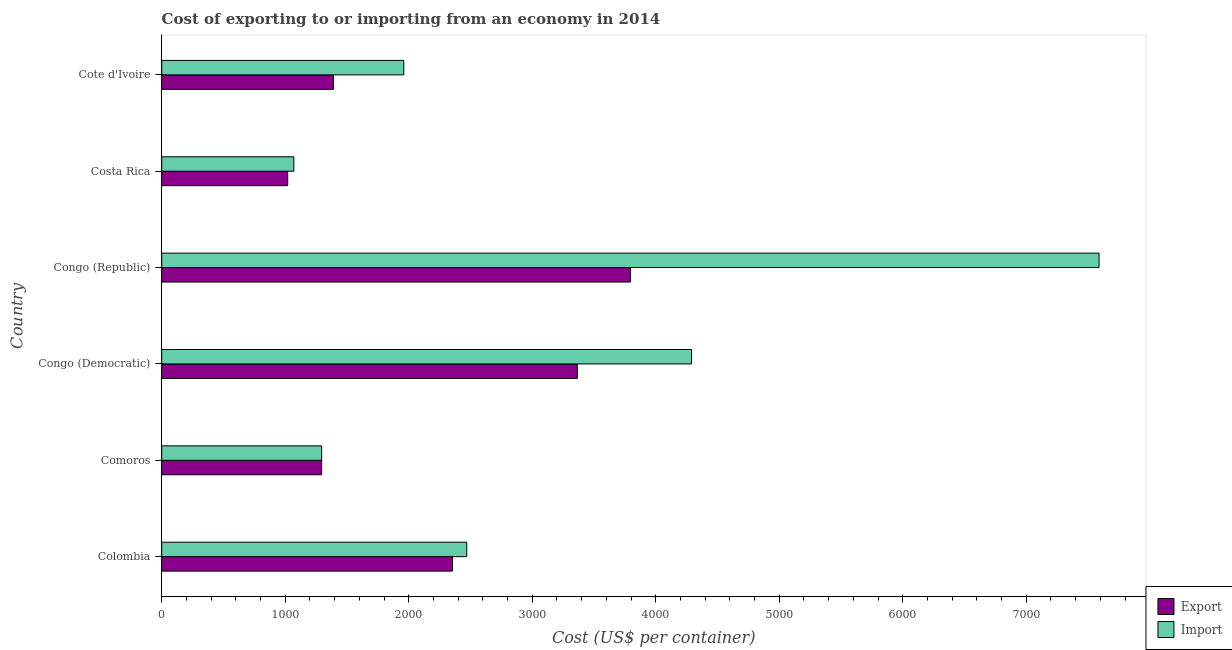Are the number of bars per tick equal to the number of legend labels?
Offer a very short reply. Yes. Are the number of bars on each tick of the Y-axis equal?
Provide a short and direct response. Yes. What is the label of the 5th group of bars from the top?
Give a very brief answer. Comoros. What is the import cost in Congo (Democratic)?
Your answer should be compact. 4290. Across all countries, what is the maximum export cost?
Keep it short and to the point. 3795. Across all countries, what is the minimum export cost?
Your answer should be very brief. 1020. In which country was the import cost maximum?
Make the answer very short. Congo (Republic). What is the total import cost in the graph?
Ensure brevity in your answer.  1.87e+04. What is the difference between the import cost in Colombia and that in Congo (Democratic)?
Keep it short and to the point. -1820. What is the difference between the export cost in Colombia and the import cost in Congo (Republic)?
Offer a terse response. -5235. What is the average export cost per country?
Make the answer very short. 2203.33. In how many countries, is the import cost greater than 7600 US$?
Make the answer very short. 0. What is the ratio of the export cost in Congo (Democratic) to that in Cote d'Ivoire?
Keep it short and to the point. 2.42. Is the export cost in Colombia less than that in Costa Rica?
Keep it short and to the point. No. Is the difference between the import cost in Comoros and Cote d'Ivoire greater than the difference between the export cost in Comoros and Cote d'Ivoire?
Your response must be concise. No. What is the difference between the highest and the second highest export cost?
Offer a very short reply. 430. What is the difference between the highest and the lowest export cost?
Ensure brevity in your answer.  2775. Is the sum of the export cost in Colombia and Cote d'Ivoire greater than the maximum import cost across all countries?
Offer a very short reply. No. What does the 2nd bar from the top in Cote d'Ivoire represents?
Keep it short and to the point. Export. What does the 2nd bar from the bottom in Costa Rica represents?
Your response must be concise. Import. How many countries are there in the graph?
Provide a short and direct response. 6. What is the difference between two consecutive major ticks on the X-axis?
Your answer should be very brief. 1000. Are the values on the major ticks of X-axis written in scientific E-notation?
Offer a terse response. No. Does the graph contain grids?
Keep it short and to the point. No. What is the title of the graph?
Make the answer very short. Cost of exporting to or importing from an economy in 2014. What is the label or title of the X-axis?
Provide a succinct answer. Cost (US$ per container). What is the Cost (US$ per container) of Export in Colombia?
Provide a short and direct response. 2355. What is the Cost (US$ per container) of Import in Colombia?
Make the answer very short. 2470. What is the Cost (US$ per container) of Export in Comoros?
Provide a short and direct response. 1295. What is the Cost (US$ per container) of Import in Comoros?
Your response must be concise. 1295. What is the Cost (US$ per container) of Export in Congo (Democratic)?
Provide a short and direct response. 3365. What is the Cost (US$ per container) of Import in Congo (Democratic)?
Provide a short and direct response. 4290. What is the Cost (US$ per container) in Export in Congo (Republic)?
Your answer should be very brief. 3795. What is the Cost (US$ per container) in Import in Congo (Republic)?
Provide a succinct answer. 7590. What is the Cost (US$ per container) in Export in Costa Rica?
Your answer should be very brief. 1020. What is the Cost (US$ per container) in Import in Costa Rica?
Offer a terse response. 1070. What is the Cost (US$ per container) in Export in Cote d'Ivoire?
Give a very brief answer. 1390. What is the Cost (US$ per container) of Import in Cote d'Ivoire?
Provide a short and direct response. 1960. Across all countries, what is the maximum Cost (US$ per container) in Export?
Provide a short and direct response. 3795. Across all countries, what is the maximum Cost (US$ per container) of Import?
Your answer should be very brief. 7590. Across all countries, what is the minimum Cost (US$ per container) in Export?
Offer a very short reply. 1020. Across all countries, what is the minimum Cost (US$ per container) of Import?
Your answer should be very brief. 1070. What is the total Cost (US$ per container) in Export in the graph?
Provide a succinct answer. 1.32e+04. What is the total Cost (US$ per container) in Import in the graph?
Make the answer very short. 1.87e+04. What is the difference between the Cost (US$ per container) of Export in Colombia and that in Comoros?
Provide a succinct answer. 1060. What is the difference between the Cost (US$ per container) in Import in Colombia and that in Comoros?
Your answer should be compact. 1175. What is the difference between the Cost (US$ per container) of Export in Colombia and that in Congo (Democratic)?
Provide a succinct answer. -1010. What is the difference between the Cost (US$ per container) of Import in Colombia and that in Congo (Democratic)?
Provide a short and direct response. -1820. What is the difference between the Cost (US$ per container) of Export in Colombia and that in Congo (Republic)?
Provide a short and direct response. -1440. What is the difference between the Cost (US$ per container) of Import in Colombia and that in Congo (Republic)?
Offer a very short reply. -5120. What is the difference between the Cost (US$ per container) in Export in Colombia and that in Costa Rica?
Make the answer very short. 1335. What is the difference between the Cost (US$ per container) in Import in Colombia and that in Costa Rica?
Make the answer very short. 1400. What is the difference between the Cost (US$ per container) of Export in Colombia and that in Cote d'Ivoire?
Your answer should be very brief. 965. What is the difference between the Cost (US$ per container) of Import in Colombia and that in Cote d'Ivoire?
Provide a succinct answer. 510. What is the difference between the Cost (US$ per container) of Export in Comoros and that in Congo (Democratic)?
Your answer should be very brief. -2070. What is the difference between the Cost (US$ per container) of Import in Comoros and that in Congo (Democratic)?
Your answer should be compact. -2995. What is the difference between the Cost (US$ per container) of Export in Comoros and that in Congo (Republic)?
Your response must be concise. -2500. What is the difference between the Cost (US$ per container) in Import in Comoros and that in Congo (Republic)?
Your answer should be very brief. -6295. What is the difference between the Cost (US$ per container) of Export in Comoros and that in Costa Rica?
Your answer should be compact. 275. What is the difference between the Cost (US$ per container) of Import in Comoros and that in Costa Rica?
Your answer should be very brief. 225. What is the difference between the Cost (US$ per container) in Export in Comoros and that in Cote d'Ivoire?
Your response must be concise. -95. What is the difference between the Cost (US$ per container) in Import in Comoros and that in Cote d'Ivoire?
Your response must be concise. -665. What is the difference between the Cost (US$ per container) in Export in Congo (Democratic) and that in Congo (Republic)?
Give a very brief answer. -430. What is the difference between the Cost (US$ per container) of Import in Congo (Democratic) and that in Congo (Republic)?
Your response must be concise. -3300. What is the difference between the Cost (US$ per container) of Export in Congo (Democratic) and that in Costa Rica?
Provide a short and direct response. 2345. What is the difference between the Cost (US$ per container) of Import in Congo (Democratic) and that in Costa Rica?
Ensure brevity in your answer.  3220. What is the difference between the Cost (US$ per container) in Export in Congo (Democratic) and that in Cote d'Ivoire?
Keep it short and to the point. 1975. What is the difference between the Cost (US$ per container) in Import in Congo (Democratic) and that in Cote d'Ivoire?
Provide a succinct answer. 2330. What is the difference between the Cost (US$ per container) in Export in Congo (Republic) and that in Costa Rica?
Your answer should be very brief. 2775. What is the difference between the Cost (US$ per container) of Import in Congo (Republic) and that in Costa Rica?
Keep it short and to the point. 6520. What is the difference between the Cost (US$ per container) of Export in Congo (Republic) and that in Cote d'Ivoire?
Your answer should be very brief. 2405. What is the difference between the Cost (US$ per container) in Import in Congo (Republic) and that in Cote d'Ivoire?
Make the answer very short. 5630. What is the difference between the Cost (US$ per container) in Export in Costa Rica and that in Cote d'Ivoire?
Your answer should be compact. -370. What is the difference between the Cost (US$ per container) in Import in Costa Rica and that in Cote d'Ivoire?
Make the answer very short. -890. What is the difference between the Cost (US$ per container) in Export in Colombia and the Cost (US$ per container) in Import in Comoros?
Offer a very short reply. 1060. What is the difference between the Cost (US$ per container) of Export in Colombia and the Cost (US$ per container) of Import in Congo (Democratic)?
Make the answer very short. -1935. What is the difference between the Cost (US$ per container) of Export in Colombia and the Cost (US$ per container) of Import in Congo (Republic)?
Keep it short and to the point. -5235. What is the difference between the Cost (US$ per container) of Export in Colombia and the Cost (US$ per container) of Import in Costa Rica?
Your response must be concise. 1285. What is the difference between the Cost (US$ per container) of Export in Colombia and the Cost (US$ per container) of Import in Cote d'Ivoire?
Offer a terse response. 395. What is the difference between the Cost (US$ per container) of Export in Comoros and the Cost (US$ per container) of Import in Congo (Democratic)?
Keep it short and to the point. -2995. What is the difference between the Cost (US$ per container) in Export in Comoros and the Cost (US$ per container) in Import in Congo (Republic)?
Your answer should be very brief. -6295. What is the difference between the Cost (US$ per container) in Export in Comoros and the Cost (US$ per container) in Import in Costa Rica?
Your response must be concise. 225. What is the difference between the Cost (US$ per container) in Export in Comoros and the Cost (US$ per container) in Import in Cote d'Ivoire?
Your response must be concise. -665. What is the difference between the Cost (US$ per container) in Export in Congo (Democratic) and the Cost (US$ per container) in Import in Congo (Republic)?
Offer a very short reply. -4225. What is the difference between the Cost (US$ per container) of Export in Congo (Democratic) and the Cost (US$ per container) of Import in Costa Rica?
Your answer should be compact. 2295. What is the difference between the Cost (US$ per container) of Export in Congo (Democratic) and the Cost (US$ per container) of Import in Cote d'Ivoire?
Provide a short and direct response. 1405. What is the difference between the Cost (US$ per container) in Export in Congo (Republic) and the Cost (US$ per container) in Import in Costa Rica?
Provide a succinct answer. 2725. What is the difference between the Cost (US$ per container) in Export in Congo (Republic) and the Cost (US$ per container) in Import in Cote d'Ivoire?
Keep it short and to the point. 1835. What is the difference between the Cost (US$ per container) of Export in Costa Rica and the Cost (US$ per container) of Import in Cote d'Ivoire?
Offer a very short reply. -940. What is the average Cost (US$ per container) in Export per country?
Ensure brevity in your answer.  2203.33. What is the average Cost (US$ per container) of Import per country?
Your answer should be compact. 3112.5. What is the difference between the Cost (US$ per container) in Export and Cost (US$ per container) in Import in Colombia?
Your answer should be very brief. -115. What is the difference between the Cost (US$ per container) in Export and Cost (US$ per container) in Import in Congo (Democratic)?
Your response must be concise. -925. What is the difference between the Cost (US$ per container) in Export and Cost (US$ per container) in Import in Congo (Republic)?
Your answer should be very brief. -3795. What is the difference between the Cost (US$ per container) of Export and Cost (US$ per container) of Import in Costa Rica?
Keep it short and to the point. -50. What is the difference between the Cost (US$ per container) of Export and Cost (US$ per container) of Import in Cote d'Ivoire?
Make the answer very short. -570. What is the ratio of the Cost (US$ per container) in Export in Colombia to that in Comoros?
Your answer should be very brief. 1.82. What is the ratio of the Cost (US$ per container) in Import in Colombia to that in Comoros?
Provide a short and direct response. 1.91. What is the ratio of the Cost (US$ per container) in Export in Colombia to that in Congo (Democratic)?
Provide a short and direct response. 0.7. What is the ratio of the Cost (US$ per container) of Import in Colombia to that in Congo (Democratic)?
Provide a succinct answer. 0.58. What is the ratio of the Cost (US$ per container) in Export in Colombia to that in Congo (Republic)?
Keep it short and to the point. 0.62. What is the ratio of the Cost (US$ per container) in Import in Colombia to that in Congo (Republic)?
Your answer should be compact. 0.33. What is the ratio of the Cost (US$ per container) in Export in Colombia to that in Costa Rica?
Ensure brevity in your answer.  2.31. What is the ratio of the Cost (US$ per container) of Import in Colombia to that in Costa Rica?
Give a very brief answer. 2.31. What is the ratio of the Cost (US$ per container) in Export in Colombia to that in Cote d'Ivoire?
Ensure brevity in your answer.  1.69. What is the ratio of the Cost (US$ per container) in Import in Colombia to that in Cote d'Ivoire?
Offer a very short reply. 1.26. What is the ratio of the Cost (US$ per container) in Export in Comoros to that in Congo (Democratic)?
Keep it short and to the point. 0.38. What is the ratio of the Cost (US$ per container) in Import in Comoros to that in Congo (Democratic)?
Your answer should be compact. 0.3. What is the ratio of the Cost (US$ per container) of Export in Comoros to that in Congo (Republic)?
Provide a short and direct response. 0.34. What is the ratio of the Cost (US$ per container) of Import in Comoros to that in Congo (Republic)?
Ensure brevity in your answer.  0.17. What is the ratio of the Cost (US$ per container) of Export in Comoros to that in Costa Rica?
Your answer should be very brief. 1.27. What is the ratio of the Cost (US$ per container) in Import in Comoros to that in Costa Rica?
Provide a succinct answer. 1.21. What is the ratio of the Cost (US$ per container) of Export in Comoros to that in Cote d'Ivoire?
Ensure brevity in your answer.  0.93. What is the ratio of the Cost (US$ per container) in Import in Comoros to that in Cote d'Ivoire?
Keep it short and to the point. 0.66. What is the ratio of the Cost (US$ per container) of Export in Congo (Democratic) to that in Congo (Republic)?
Make the answer very short. 0.89. What is the ratio of the Cost (US$ per container) of Import in Congo (Democratic) to that in Congo (Republic)?
Provide a short and direct response. 0.57. What is the ratio of the Cost (US$ per container) of Export in Congo (Democratic) to that in Costa Rica?
Your answer should be compact. 3.3. What is the ratio of the Cost (US$ per container) of Import in Congo (Democratic) to that in Costa Rica?
Your response must be concise. 4.01. What is the ratio of the Cost (US$ per container) in Export in Congo (Democratic) to that in Cote d'Ivoire?
Your answer should be compact. 2.42. What is the ratio of the Cost (US$ per container) of Import in Congo (Democratic) to that in Cote d'Ivoire?
Your answer should be very brief. 2.19. What is the ratio of the Cost (US$ per container) of Export in Congo (Republic) to that in Costa Rica?
Ensure brevity in your answer.  3.72. What is the ratio of the Cost (US$ per container) of Import in Congo (Republic) to that in Costa Rica?
Your response must be concise. 7.09. What is the ratio of the Cost (US$ per container) of Export in Congo (Republic) to that in Cote d'Ivoire?
Ensure brevity in your answer.  2.73. What is the ratio of the Cost (US$ per container) of Import in Congo (Republic) to that in Cote d'Ivoire?
Offer a very short reply. 3.87. What is the ratio of the Cost (US$ per container) of Export in Costa Rica to that in Cote d'Ivoire?
Ensure brevity in your answer.  0.73. What is the ratio of the Cost (US$ per container) of Import in Costa Rica to that in Cote d'Ivoire?
Your answer should be very brief. 0.55. What is the difference between the highest and the second highest Cost (US$ per container) of Export?
Provide a short and direct response. 430. What is the difference between the highest and the second highest Cost (US$ per container) in Import?
Offer a very short reply. 3300. What is the difference between the highest and the lowest Cost (US$ per container) in Export?
Your answer should be very brief. 2775. What is the difference between the highest and the lowest Cost (US$ per container) of Import?
Make the answer very short. 6520. 